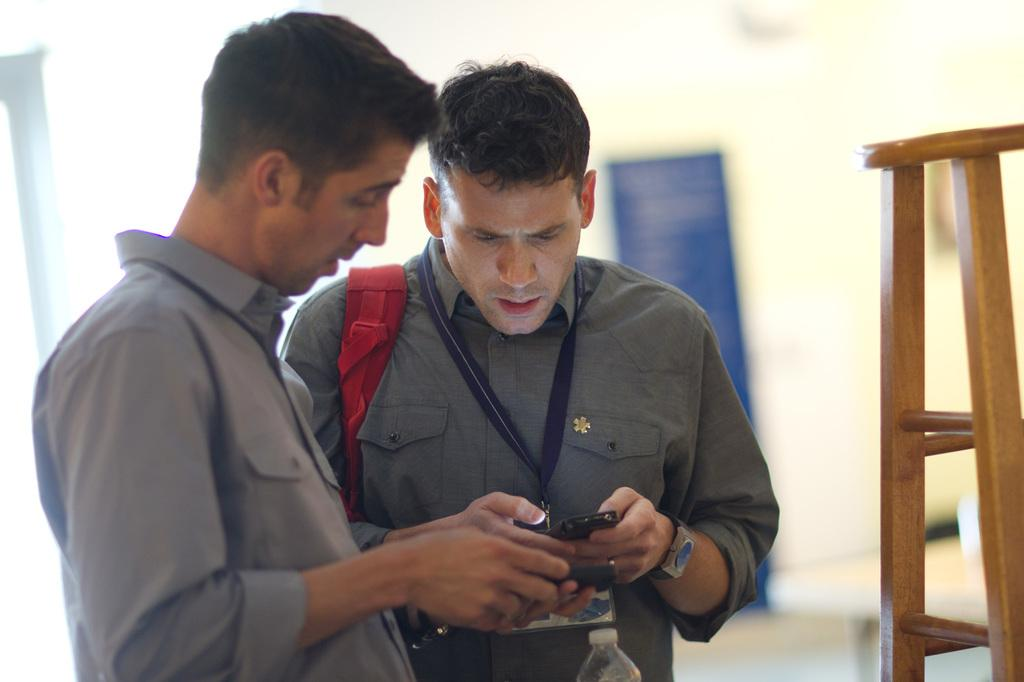How many people are in the image? There are two persons in the image. What are the persons doing in the image? The persons are standing and holding a mobile phone in their hands. Can you describe any objects in the image besides the persons? Yes, there is a wooden stool on the right side of the image. What type of wood is the hammer made of in the image? There is no hammer present in the image. 